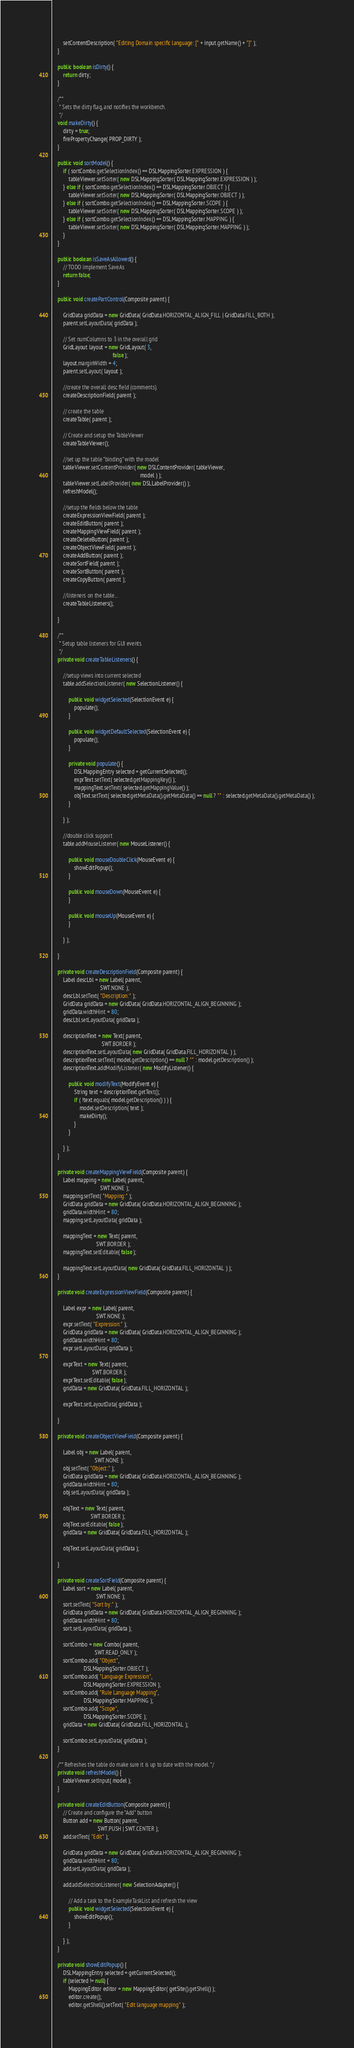Convert code to text. <code><loc_0><loc_0><loc_500><loc_500><_Java_>        setContentDescription( "Editing Domain specific language: [" + input.getName() + "]" );
    }

    public boolean isDirty() {
        return dirty;
    }

    /**
     * Sets the dirty flag, and notifies the workbench.
     */
    void makeDirty() {
        dirty = true;
        firePropertyChange( PROP_DIRTY );
    }

    public void sortModel() {
        if ( sortCombo.getSelectionIndex() == DSLMappingSorter.EXPRESSION ) {
            tableViewer.setSorter( new DSLMappingSorter( DSLMappingSorter.EXPRESSION ) );
        } else if ( sortCombo.getSelectionIndex() == DSLMappingSorter.OBJECT ) {
            tableViewer.setSorter( new DSLMappingSorter( DSLMappingSorter.OBJECT ) );
        } else if ( sortCombo.getSelectionIndex() == DSLMappingSorter.SCOPE ) {
            tableViewer.setSorter( new DSLMappingSorter( DSLMappingSorter.SCOPE ) );
        } else if ( sortCombo.getSelectionIndex() == DSLMappingSorter.MAPPING ) {
            tableViewer.setSorter( new DSLMappingSorter( DSLMappingSorter.MAPPING ) );
        }
    }

    public boolean isSaveAsAllowed() {
        // TODO implement SaveAs
        return false;
    }

    public void createPartControl(Composite parent) {

        GridData gridData = new GridData( GridData.HORIZONTAL_ALIGN_FILL | GridData.FILL_BOTH );
        parent.setLayoutData( gridData );

        // Set numColumns to 3 in the overall grid
        GridLayout layout = new GridLayout( 3,
                                            false );
        layout.marginWidth = 4;
        parent.setLayout( layout );

        //create the overall desc field (comments).
        createDescriptionField( parent );

        // create the table
        createTable( parent );

        // Create and setup the TableViewer
        createTableViewer();

        //set up the table "binding" with the model
        tableViewer.setContentProvider( new DSLContentProvider( tableViewer,
                                                                model ) );
        tableViewer.setLabelProvider( new DSLLabelProvider() );
        refreshModel();

        //setup the fields below the table
        createExpressionViewField( parent );
        createEditButton( parent );
        createMappingViewField( parent );
        createDeleteButton( parent );
        createObjectViewField( parent );
        createAddButton( parent );
        createSortField( parent );
        createSortButton( parent );
        createCopyButton( parent );

        //listeners on the table...
        createTableListeners();

    }

    /**
     * Setup table listeners for GUI events.
     */
    private void createTableListeners() {

        //setup views into current selected
        table.addSelectionListener( new SelectionListener() {

            public void widgetSelected(SelectionEvent e) {
                populate();
            }

            public void widgetDefaultSelected(SelectionEvent e) {
                populate();
            }

            private void populate() {
                DSLMappingEntry selected = getCurrentSelected();
                exprText.setText( selected.getMappingKey() );
                mappingText.setText( selected.getMappingValue() );
                objText.setText( selected.getMetaData().getMetaData() == null ? "" : selected.getMetaData().getMetaData() );
            }

        } );

        //double click support
        table.addMouseListener( new MouseListener() {

            public void mouseDoubleClick(MouseEvent e) {
                showEditPopup();
            }

            public void mouseDown(MouseEvent e) {
            }

            public void mouseUp(MouseEvent e) {
            }

        } );

    }

    private void createDescriptionField(Composite parent) {
        Label descLbl = new Label( parent,
                                   SWT.NONE );
        descLbl.setText( "Description:" );
        GridData gridData = new GridData( GridData.HORIZONTAL_ALIGN_BEGINNING );
        gridData.widthHint = 80;
        descLbl.setLayoutData( gridData );

        descriptionText = new Text( parent,
                                    SWT.BORDER );
        descriptionText.setLayoutData( new GridData( GridData.FILL_HORIZONTAL ) );
        descriptionText.setText( model.getDescription() == null ? "" : model.getDescription() );
        descriptionText.addModifyListener( new ModifyListener() {

            public void modifyText(ModifyEvent e) {
                String text = descriptionText.getText();
                if ( !text.equals( model.getDescription() ) ) {
                    model.setDescription( text );
                    makeDirty();
                }
            }

        } );
    }

    private void createMappingViewField(Composite parent) {
        Label mapping = new Label( parent,
                                   SWT.NONE );
        mapping.setText( "Mapping:" );
        GridData gridData = new GridData( GridData.HORIZONTAL_ALIGN_BEGINNING );
        gridData.widthHint = 80;
        mapping.setLayoutData( gridData );

        mappingText = new Text( parent,
                                SWT.BORDER );
        mappingText.setEditable( false );

        mappingText.setLayoutData( new GridData( GridData.FILL_HORIZONTAL ) );
    }

    private void createExpressionViewField(Composite parent) {

        Label expr = new Label( parent,
                                SWT.NONE );
        expr.setText( "Expression:" );
        GridData gridData = new GridData( GridData.HORIZONTAL_ALIGN_BEGINNING );
        gridData.widthHint = 80;
        expr.setLayoutData( gridData );

        exprText = new Text( parent,
                             SWT.BORDER );
        exprText.setEditable( false );
        gridData = new GridData( GridData.FILL_HORIZONTAL );

        exprText.setLayoutData( gridData );

    }

    private void createObjectViewField(Composite parent) {

        Label obj = new Label( parent,
                               SWT.NONE );
        obj.setText( "Object:" );
        GridData gridData = new GridData( GridData.HORIZONTAL_ALIGN_BEGINNING );
        gridData.widthHint = 80;
        obj.setLayoutData( gridData );

        objText = new Text( parent,
                            SWT.BORDER );
        objText.setEditable( false );
        gridData = new GridData( GridData.FILL_HORIZONTAL );

        objText.setLayoutData( gridData );

    }

    private void createSortField(Composite parent) {
        Label sort = new Label( parent,
                                SWT.NONE );
        sort.setText( "Sort by:" );
        GridData gridData = new GridData( GridData.HORIZONTAL_ALIGN_BEGINNING );
        gridData.widthHint = 80;
        sort.setLayoutData( gridData );

        sortCombo = new Combo( parent,
                               SWT.READ_ONLY );
        sortCombo.add( "Object",
                       DSLMappingSorter.OBJECT );
        sortCombo.add( "Language Expression",
                       DSLMappingSorter.EXPRESSION );
        sortCombo.add( "Rule Language Mapping",
                       DSLMappingSorter.MAPPING );
        sortCombo.add( "Scope",
                       DSLMappingSorter.SCOPE );
        gridData = new GridData( GridData.FILL_HORIZONTAL );

        sortCombo.setLayoutData( gridData );
    }

    /** Refreshes the table do make sure it is up to date with the model. */
    private void refreshModel() {
        tableViewer.setInput( model );
    }

    private void createEditButton(Composite parent) {
        // Create and configure the "Add" button
        Button add = new Button( parent,
                                 SWT.PUSH | SWT.CENTER );
        add.setText( "Edit" );

        GridData gridData = new GridData( GridData.HORIZONTAL_ALIGN_BEGINNING );
        gridData.widthHint = 80;
        add.setLayoutData( gridData );

        add.addSelectionListener( new SelectionAdapter() {

            // Add a task to the ExampleTaskList and refresh the view
            public void widgetSelected(SelectionEvent e) {
                showEditPopup();
            }

        } );
    }

    private void showEditPopup() {
        DSLMappingEntry selected = getCurrentSelected();
        if (selected != null) {
            MappingEditor editor = new MappingEditor( getSite().getShell() );
            editor.create();
            editor.getShell().setText( "Edit language mapping" );</code> 